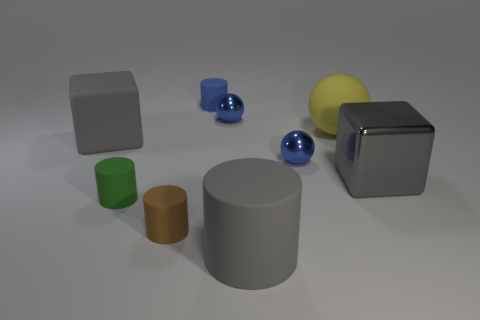Could you tell me the lighting condition of this scene? Certainly, the scene is illuminated by soft, diffused lighting, possibly from an overhead source. The shadows cast by the objects are soft and not very pronounced, suggesting the light is not harsh or coming from a single point source. This type of lighting tends to minimize texture and surface detail which creates a calm and simple visual effect. 